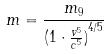Convert formula to latex. <formula><loc_0><loc_0><loc_500><loc_500>m = \frac { m _ { 9 } } { ( { 1 \cdot \frac { v ^ { 5 } } { c ^ { 5 } } ) } ^ { 4 / 5 } }</formula> 